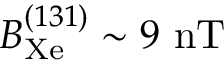Convert formula to latex. <formula><loc_0><loc_0><loc_500><loc_500>B _ { X e } ^ { ( 1 3 1 ) } \sim 9 n T</formula> 